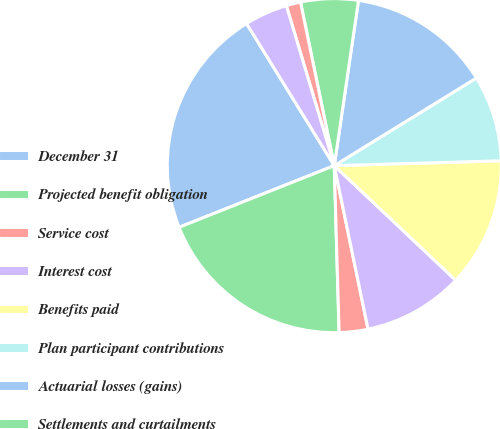Convert chart to OTSL. <chart><loc_0><loc_0><loc_500><loc_500><pie_chart><fcel>December 31<fcel>Projected benefit obligation<fcel>Service cost<fcel>Interest cost<fcel>Benefits paid<fcel>Plan participant contributions<fcel>Actuarial losses (gains)<fcel>Settlements and curtailments<fcel>Foreign currency effect<fcel>Other<nl><fcel>22.22%<fcel>19.44%<fcel>2.78%<fcel>9.72%<fcel>12.5%<fcel>8.33%<fcel>13.89%<fcel>5.56%<fcel>1.39%<fcel>4.17%<nl></chart> 